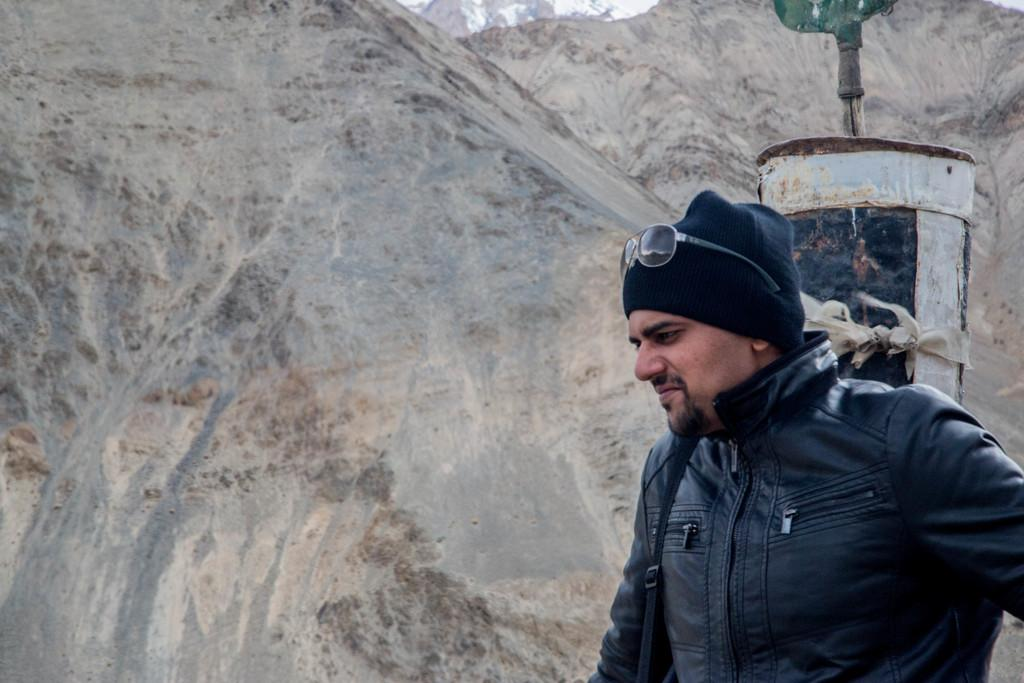Who is present in the image? There is a man in the picture. What can be seen in the image besides the man? There is an object in the picture. What is visible in the background of the image? There are mountains in the background of the picture. What type of marble is the man using to calculate profit in the image? There is no marble or calculation of profit present in the image. 